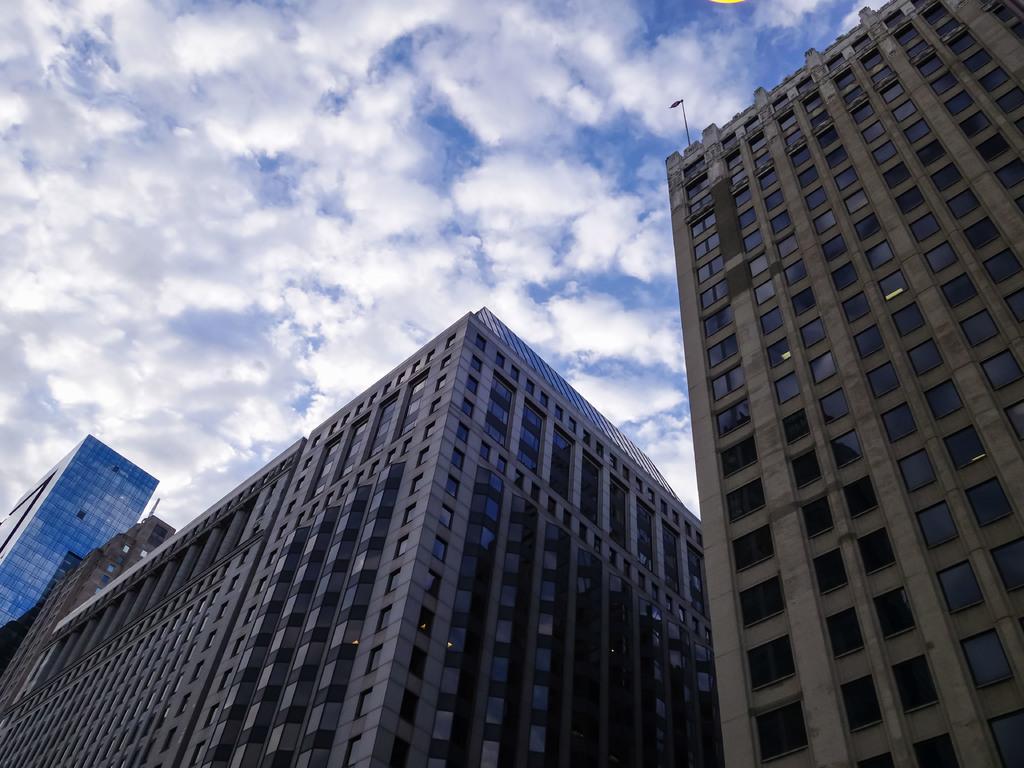In one or two sentences, can you explain what this image depicts? In the foreground of the image we can see the buildings. In the middle of the image we can see the building and the flag. On the top of the image we can see the sky. 